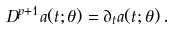Convert formula to latex. <formula><loc_0><loc_0><loc_500><loc_500>D ^ { p + 1 } a ( t ; \theta ) = \partial _ { t } a ( t ; \theta ) \, .</formula> 